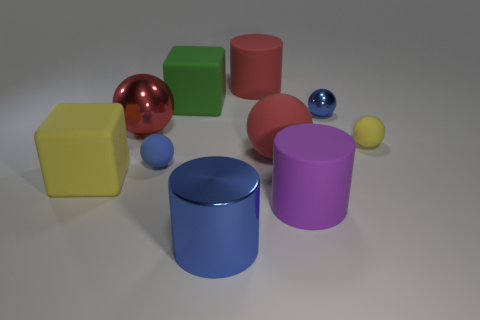Subtract 2 balls. How many balls are left? 3 Subtract all large red metallic balls. How many balls are left? 4 Subtract all yellow balls. How many balls are left? 4 Subtract all brown balls. Subtract all cyan cubes. How many balls are left? 5 Subtract all cylinders. How many objects are left? 7 Add 1 small cyan shiny blocks. How many small cyan shiny blocks exist? 1 Subtract 0 green balls. How many objects are left? 10 Subtract all cubes. Subtract all small purple metal balls. How many objects are left? 8 Add 5 tiny yellow matte objects. How many tiny yellow matte objects are left? 6 